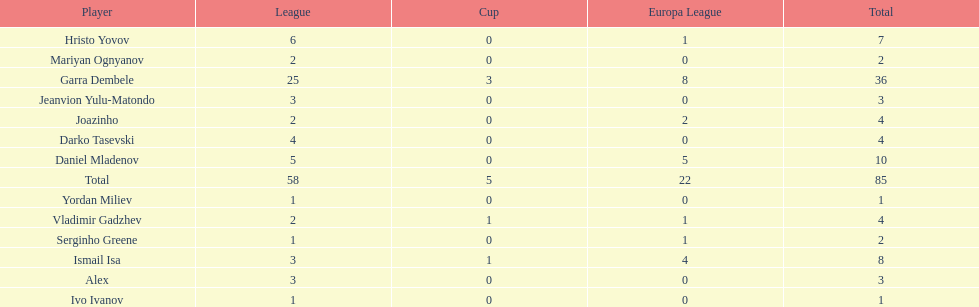How many goals did ismail isa score this season? 8. 